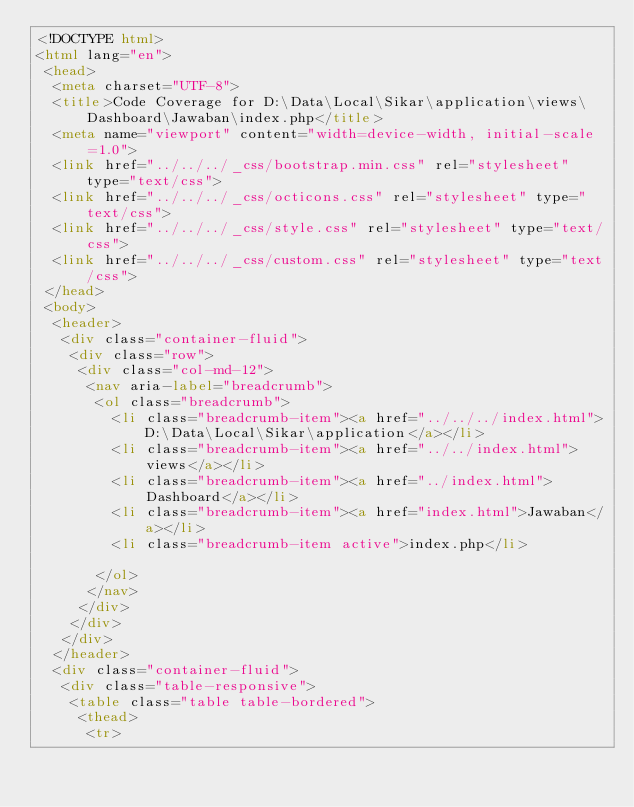<code> <loc_0><loc_0><loc_500><loc_500><_HTML_><!DOCTYPE html>
<html lang="en">
 <head>
  <meta charset="UTF-8">
  <title>Code Coverage for D:\Data\Local\Sikar\application\views\Dashboard\Jawaban\index.php</title>
  <meta name="viewport" content="width=device-width, initial-scale=1.0">
  <link href="../../../_css/bootstrap.min.css" rel="stylesheet" type="text/css">
  <link href="../../../_css/octicons.css" rel="stylesheet" type="text/css">
  <link href="../../../_css/style.css" rel="stylesheet" type="text/css">
  <link href="../../../_css/custom.css" rel="stylesheet" type="text/css">
 </head>
 <body>
  <header>
   <div class="container-fluid">
    <div class="row">
     <div class="col-md-12">
      <nav aria-label="breadcrumb">
       <ol class="breadcrumb">
         <li class="breadcrumb-item"><a href="../../../index.html">D:\Data\Local\Sikar\application</a></li>
         <li class="breadcrumb-item"><a href="../../index.html">views</a></li>
         <li class="breadcrumb-item"><a href="../index.html">Dashboard</a></li>
         <li class="breadcrumb-item"><a href="index.html">Jawaban</a></li>
         <li class="breadcrumb-item active">index.php</li>

       </ol>
      </nav>
     </div>
    </div>
   </div>
  </header>
  <div class="container-fluid">
   <div class="table-responsive">
    <table class="table table-bordered">
     <thead>
      <tr></code> 